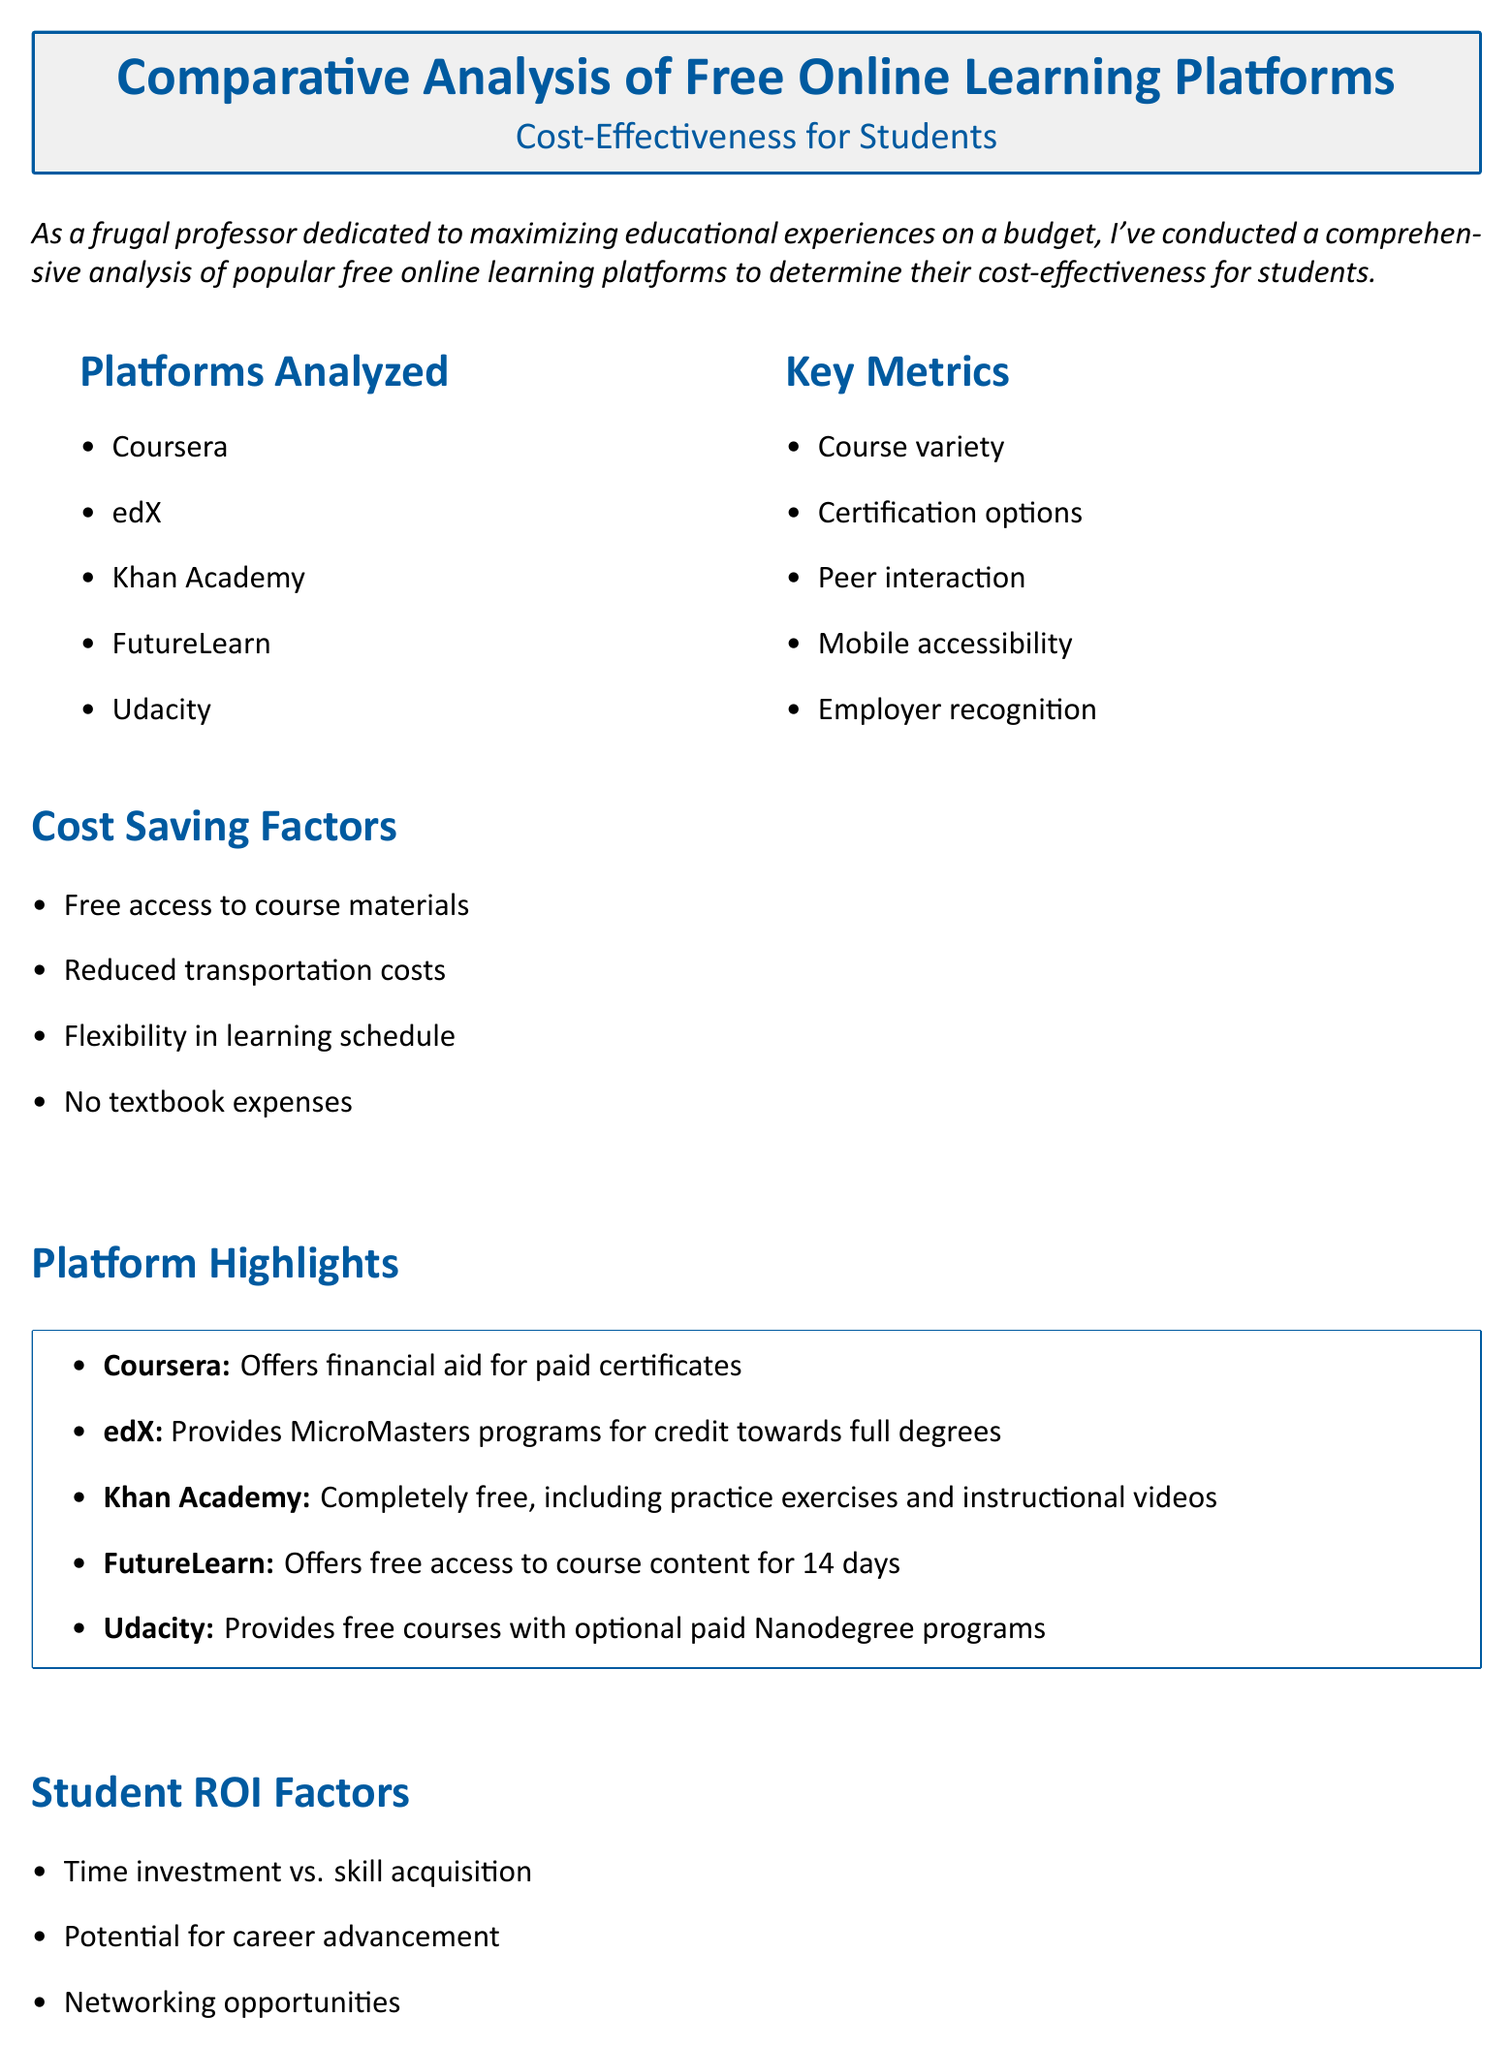What platforms were analyzed? The platforms analyzed are listed in the document under "Platforms Analyzed."
Answer: Coursera, edX, Khan Academy, FutureLearn, Udacity What are the key metrics mentioned? Key metrics are specified in the "Key Metrics" section of the document.
Answer: Course variety, Certification options, Peer interaction, Mobile accessibility, Employer recognition Which platform is completely free? The document states that one platform offers completely free access, emphasizing its unique highlight.
Answer: Khan Academy What cost-saving factor eliminates textbook expenses? The cost-saving factors are listed and one of them directly refers to expenses related to textbooks.
Answer: No textbook expenses What is the highlighted feature of edX? The unique feature of edX is described in the "Platform Highlights" section.
Answer: Provides MicroMasters programs for credit towards full degrees What should students consider when choosing a platform? The conclusion advises students on what factors to consider related to their choices.
Answer: Specific learning goals and career aspirations How many platforms does the document analyze? The number of platforms is determined by counting the items listed under "Platforms Analyzed."
Answer: Five What financial aid option does Coursera offer? The document provides a specific financial aid opportunity related to Coursera.
Answer: Financial aid for paid certificates 